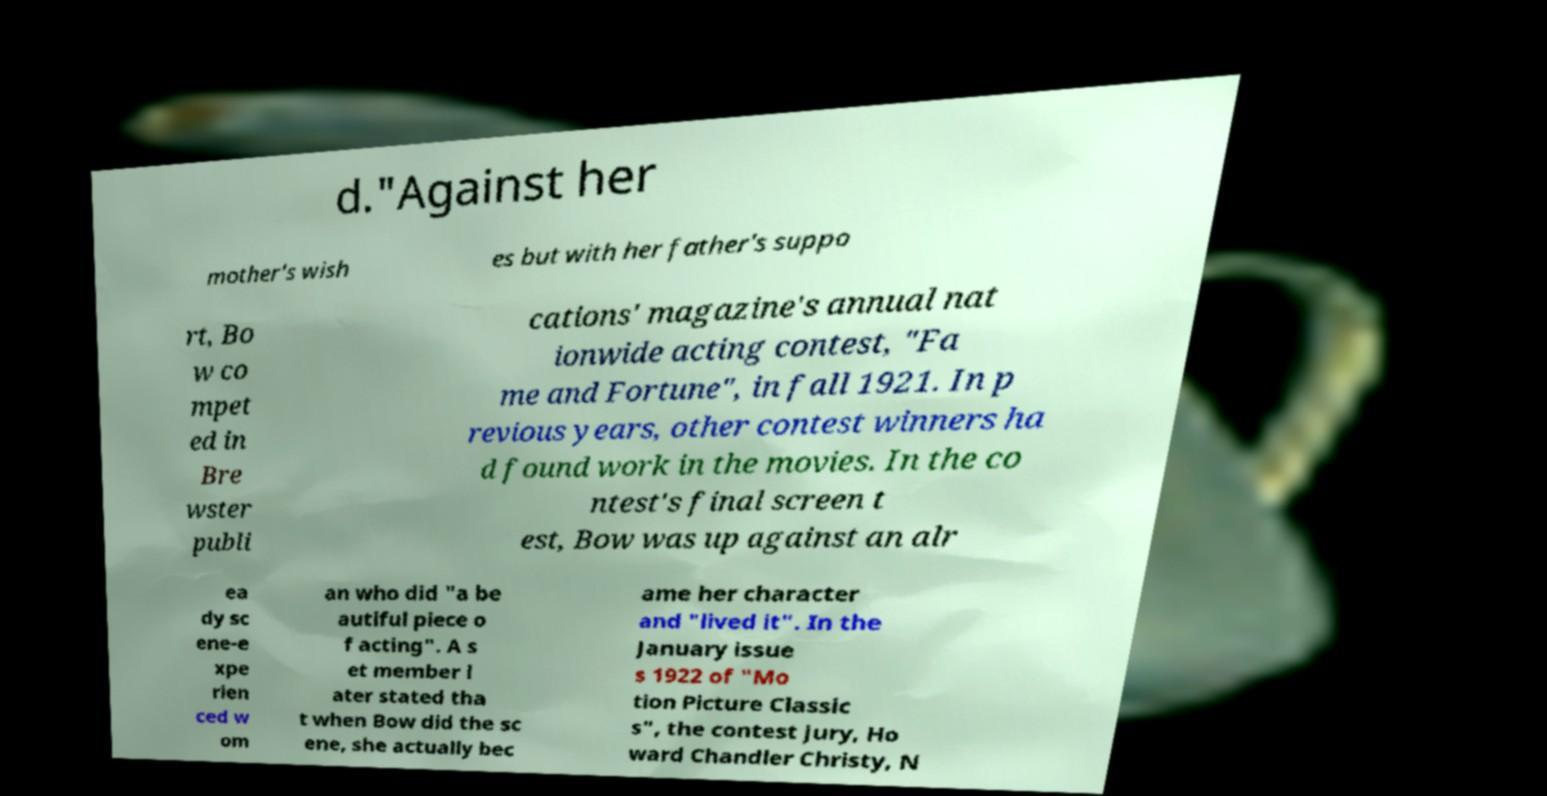Please read and relay the text visible in this image. What does it say? d."Against her mother's wish es but with her father's suppo rt, Bo w co mpet ed in Bre wster publi cations' magazine's annual nat ionwide acting contest, "Fa me and Fortune", in fall 1921. In p revious years, other contest winners ha d found work in the movies. In the co ntest's final screen t est, Bow was up against an alr ea dy sc ene-e xpe rien ced w om an who did "a be autiful piece o f acting". A s et member l ater stated tha t when Bow did the sc ene, she actually bec ame her character and "lived it". In the January issue s 1922 of "Mo tion Picture Classic s", the contest jury, Ho ward Chandler Christy, N 